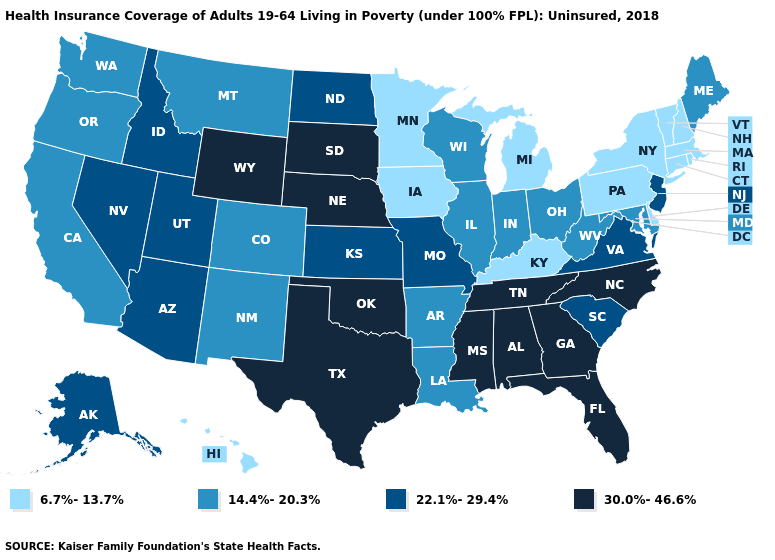What is the value of Alaska?
Answer briefly. 22.1%-29.4%. Which states have the highest value in the USA?
Keep it brief. Alabama, Florida, Georgia, Mississippi, Nebraska, North Carolina, Oklahoma, South Dakota, Tennessee, Texas, Wyoming. Name the states that have a value in the range 30.0%-46.6%?
Keep it brief. Alabama, Florida, Georgia, Mississippi, Nebraska, North Carolina, Oklahoma, South Dakota, Tennessee, Texas, Wyoming. Name the states that have a value in the range 22.1%-29.4%?
Write a very short answer. Alaska, Arizona, Idaho, Kansas, Missouri, Nevada, New Jersey, North Dakota, South Carolina, Utah, Virginia. Is the legend a continuous bar?
Write a very short answer. No. Is the legend a continuous bar?
Keep it brief. No. Name the states that have a value in the range 22.1%-29.4%?
Keep it brief. Alaska, Arizona, Idaho, Kansas, Missouri, Nevada, New Jersey, North Dakota, South Carolina, Utah, Virginia. Does Hawaii have a lower value than Michigan?
Quick response, please. No. What is the value of Alaska?
Answer briefly. 22.1%-29.4%. Among the states that border Kansas , which have the highest value?
Write a very short answer. Nebraska, Oklahoma. What is the lowest value in the MidWest?
Be succinct. 6.7%-13.7%. What is the value of Nevada?
Write a very short answer. 22.1%-29.4%. What is the value of Georgia?
Answer briefly. 30.0%-46.6%. What is the value of Nebraska?
Concise answer only. 30.0%-46.6%. 